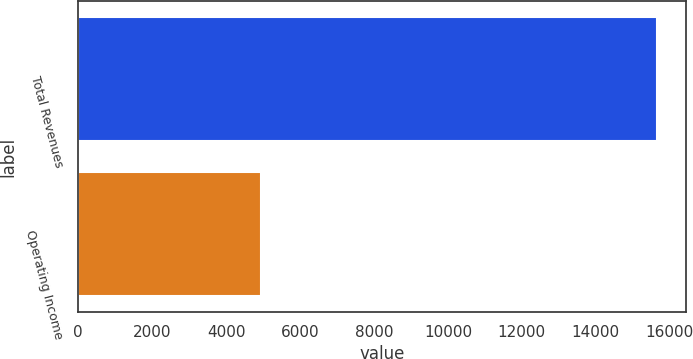Convert chart. <chart><loc_0><loc_0><loc_500><loc_500><bar_chart><fcel>Total Revenues<fcel>Operating Income<nl><fcel>15649<fcel>4943<nl></chart> 